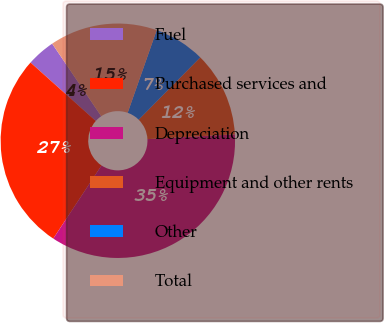Convert chart. <chart><loc_0><loc_0><loc_500><loc_500><pie_chart><fcel>Fuel<fcel>Purchased services and<fcel>Depreciation<fcel>Equipment and other rents<fcel>Other<fcel>Total<nl><fcel>3.91%<fcel>27.34%<fcel>35.16%<fcel>11.72%<fcel>7.03%<fcel>14.84%<nl></chart> 